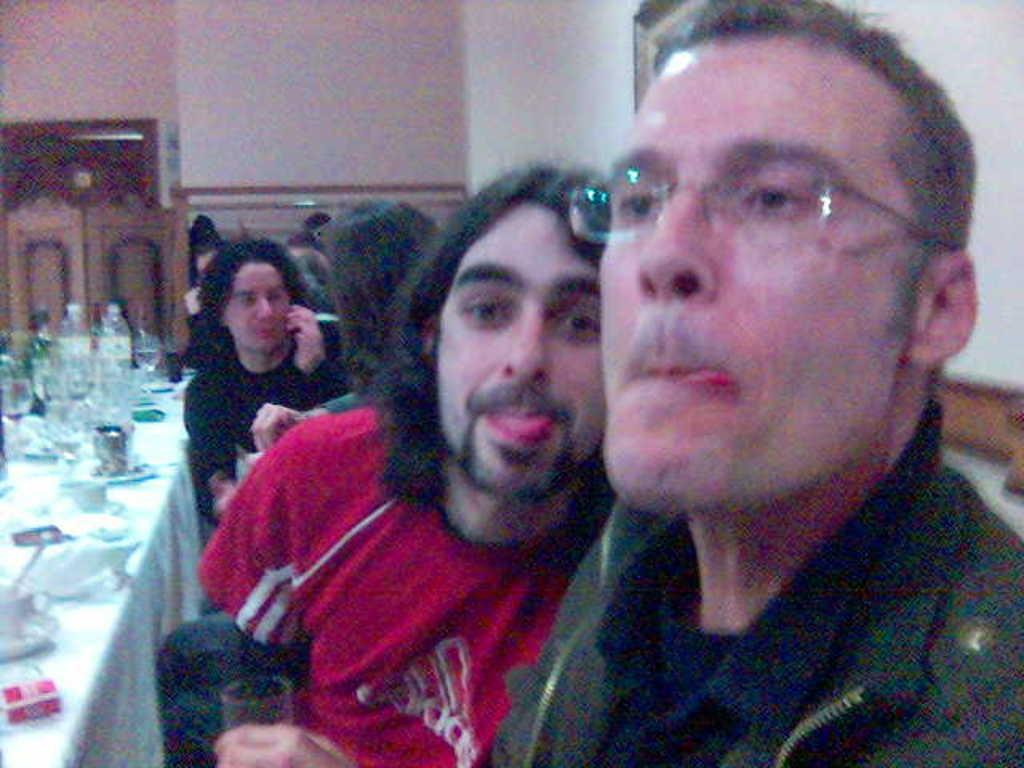What are the persons in the image doing? The persons in the image are sitting on chairs. What is in front of the persons? There is a table in front of the persons. How is the table decorated or covered? The table is covered with a cloth. What items can be seen on the table? There are water bottles and crockery on the table. What type of plot is being discussed by the persons in the image? There is no indication of a plot or discussion in the image; it simply shows persons sitting on chairs with a table in front of them. 